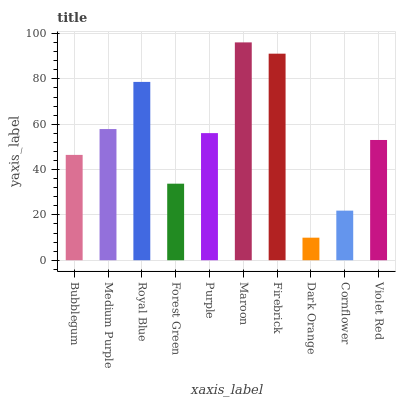Is Dark Orange the minimum?
Answer yes or no. Yes. Is Maroon the maximum?
Answer yes or no. Yes. Is Medium Purple the minimum?
Answer yes or no. No. Is Medium Purple the maximum?
Answer yes or no. No. Is Medium Purple greater than Bubblegum?
Answer yes or no. Yes. Is Bubblegum less than Medium Purple?
Answer yes or no. Yes. Is Bubblegum greater than Medium Purple?
Answer yes or no. No. Is Medium Purple less than Bubblegum?
Answer yes or no. No. Is Purple the high median?
Answer yes or no. Yes. Is Violet Red the low median?
Answer yes or no. Yes. Is Medium Purple the high median?
Answer yes or no. No. Is Purple the low median?
Answer yes or no. No. 